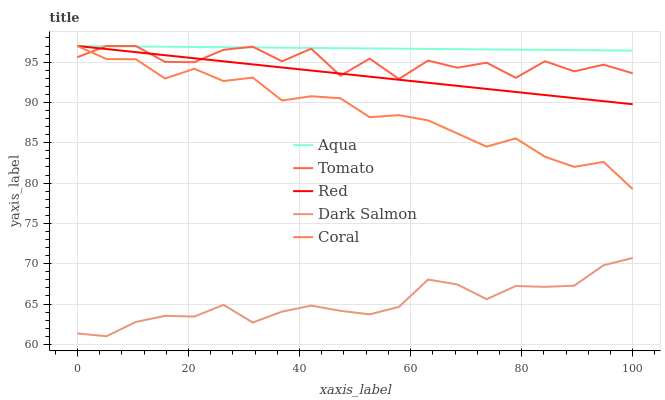Does Dark Salmon have the minimum area under the curve?
Answer yes or no. Yes. Does Aqua have the maximum area under the curve?
Answer yes or no. Yes. Does Coral have the minimum area under the curve?
Answer yes or no. No. Does Coral have the maximum area under the curve?
Answer yes or no. No. Is Aqua the smoothest?
Answer yes or no. Yes. Is Tomato the roughest?
Answer yes or no. Yes. Is Coral the smoothest?
Answer yes or no. No. Is Coral the roughest?
Answer yes or no. No. Does Dark Salmon have the lowest value?
Answer yes or no. Yes. Does Coral have the lowest value?
Answer yes or no. No. Does Red have the highest value?
Answer yes or no. Yes. Does Dark Salmon have the highest value?
Answer yes or no. No. Is Dark Salmon less than Tomato?
Answer yes or no. Yes. Is Coral greater than Dark Salmon?
Answer yes or no. Yes. Does Coral intersect Tomato?
Answer yes or no. Yes. Is Coral less than Tomato?
Answer yes or no. No. Is Coral greater than Tomato?
Answer yes or no. No. Does Dark Salmon intersect Tomato?
Answer yes or no. No. 